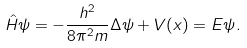Convert formula to latex. <formula><loc_0><loc_0><loc_500><loc_500>\hat { H } \psi = - \frac { h ^ { 2 } } { 8 \pi ^ { 2 } m } \Delta \psi + V ( x ) = E \psi .</formula> 